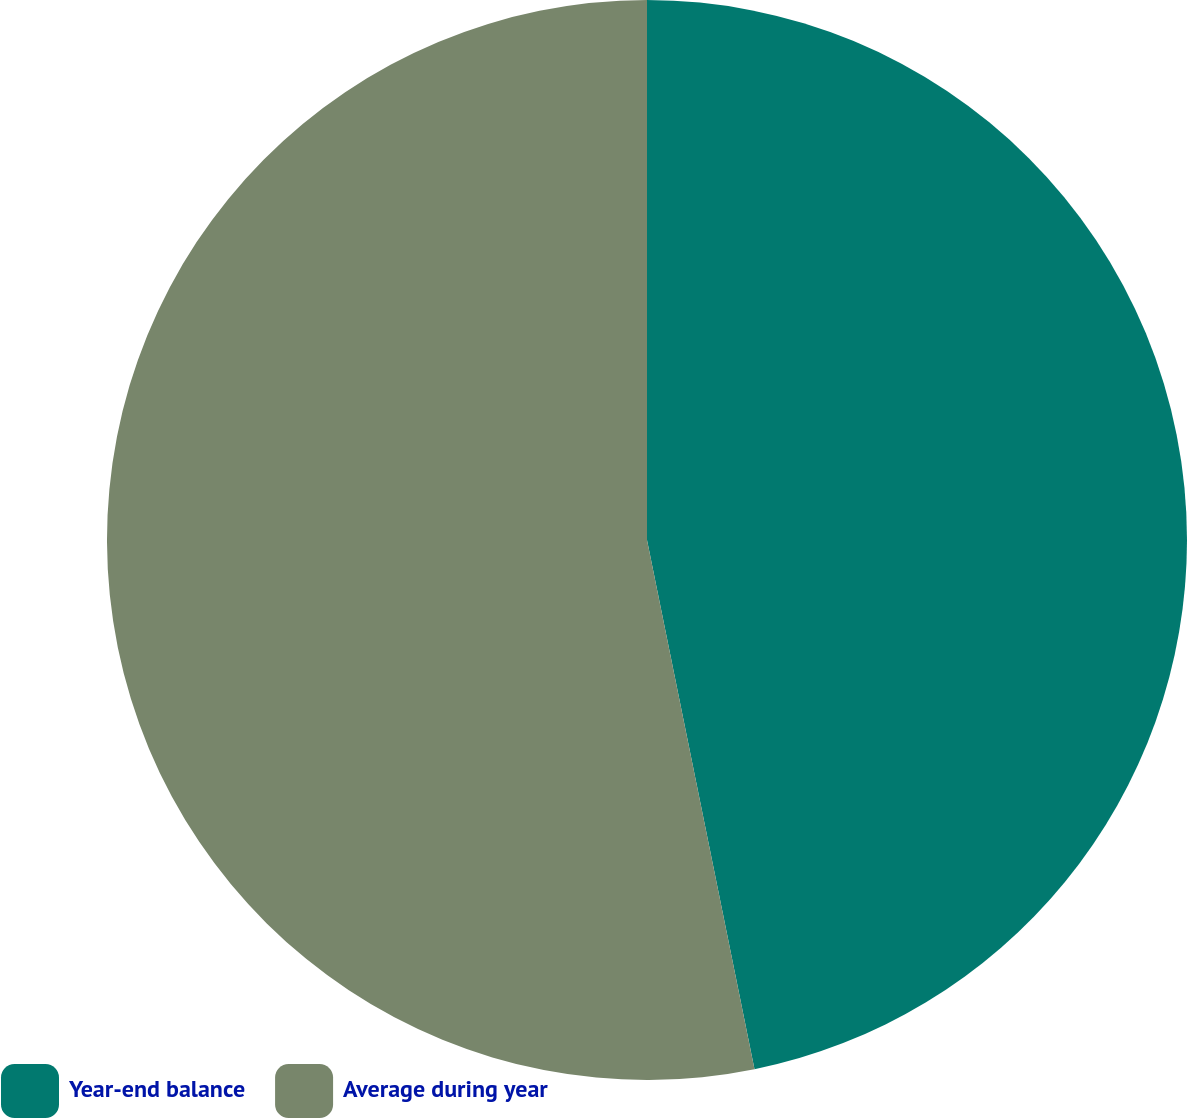Convert chart. <chart><loc_0><loc_0><loc_500><loc_500><pie_chart><fcel>Year-end balance<fcel>Average during year<nl><fcel>46.81%<fcel>53.19%<nl></chart> 